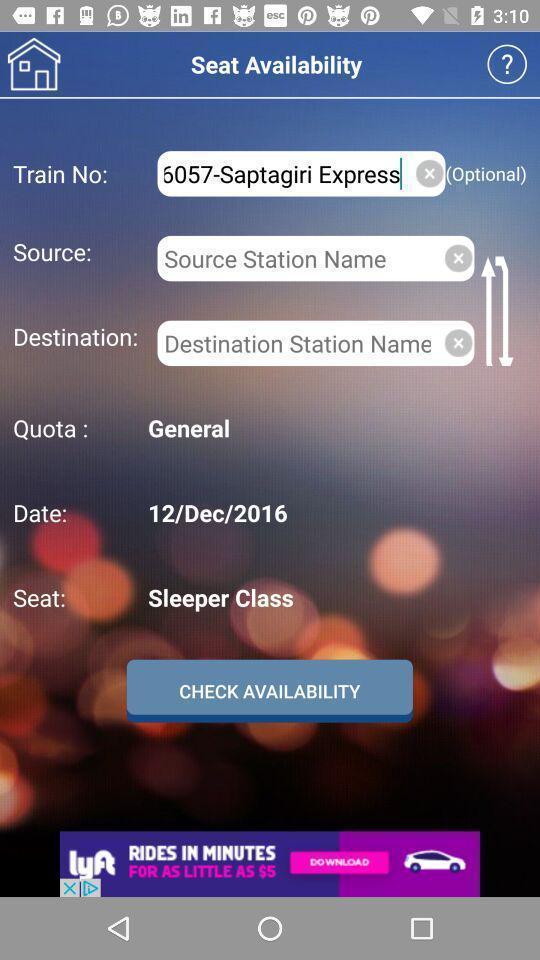Provide a detailed account of this screenshot. Page showing multiple seat availability options in a travel app. 